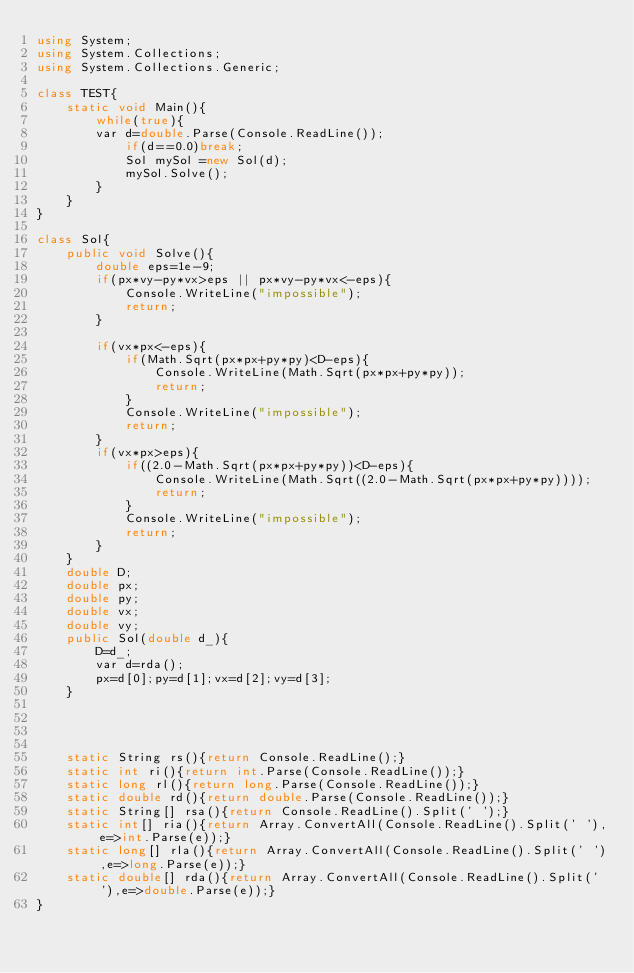<code> <loc_0><loc_0><loc_500><loc_500><_C#_>using System;
using System.Collections;
using System.Collections.Generic;
 
class TEST{
	static void Main(){
		while(true){
		var d=double.Parse(Console.ReadLine());
			if(d==0.0)break;
			Sol mySol =new Sol(d);
			mySol.Solve();
		}
	}
}

class Sol{
	public void Solve(){
		double eps=1e-9;
		if(px*vy-py*vx>eps || px*vy-py*vx<-eps){
			Console.WriteLine("impossible");
			return;
		}
		
		if(vx*px<-eps){
			if(Math.Sqrt(px*px+py*py)<D-eps){
				Console.WriteLine(Math.Sqrt(px*px+py*py));
				return;
			}
			Console.WriteLine("impossible");
			return;
		}
		if(vx*px>eps){
			if((2.0-Math.Sqrt(px*px+py*py))<D-eps){
				Console.WriteLine(Math.Sqrt((2.0-Math.Sqrt(px*px+py*py))));
				return;
			}
			Console.WriteLine("impossible");
			return;
		}
	}
	double D;
	double px;
	double py;
	double vx;
	double vy;
	public Sol(double d_){
		D=d_;
		var d=rda();
		px=d[0];py=d[1];vx=d[2];vy=d[3];
	}




	static String rs(){return Console.ReadLine();}
	static int ri(){return int.Parse(Console.ReadLine());}
	static long rl(){return long.Parse(Console.ReadLine());}
	static double rd(){return double.Parse(Console.ReadLine());}
	static String[] rsa(){return Console.ReadLine().Split(' ');}
	static int[] ria(){return Array.ConvertAll(Console.ReadLine().Split(' '),e=>int.Parse(e));}
	static long[] rla(){return Array.ConvertAll(Console.ReadLine().Split(' '),e=>long.Parse(e));}
	static double[] rda(){return Array.ConvertAll(Console.ReadLine().Split(' '),e=>double.Parse(e));}
}</code> 